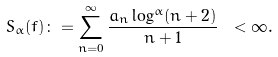<formula> <loc_0><loc_0><loc_500><loc_500>S _ { \alpha } ( f ) \colon = \sum _ { n = 0 } ^ { \infty } \frac { a _ { n } \log ^ { \alpha } ( n + 2 ) } { n + 1 } \ < \infty .</formula> 